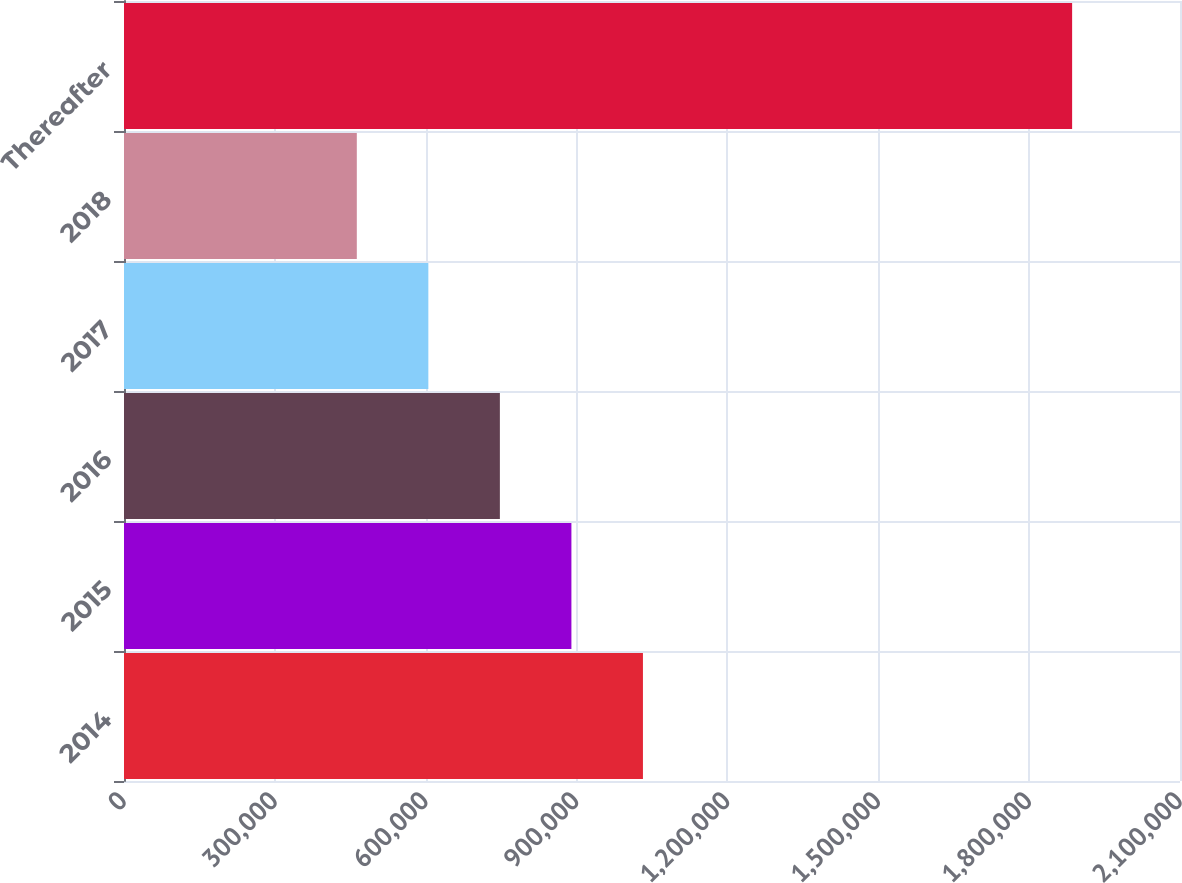Convert chart. <chart><loc_0><loc_0><loc_500><loc_500><bar_chart><fcel>2014<fcel>2015<fcel>2016<fcel>2017<fcel>2018<fcel>Thereafter<nl><fcel>1.03198e+06<fcel>889732<fcel>747484<fcel>605235<fcel>462986<fcel>1.88547e+06<nl></chart> 